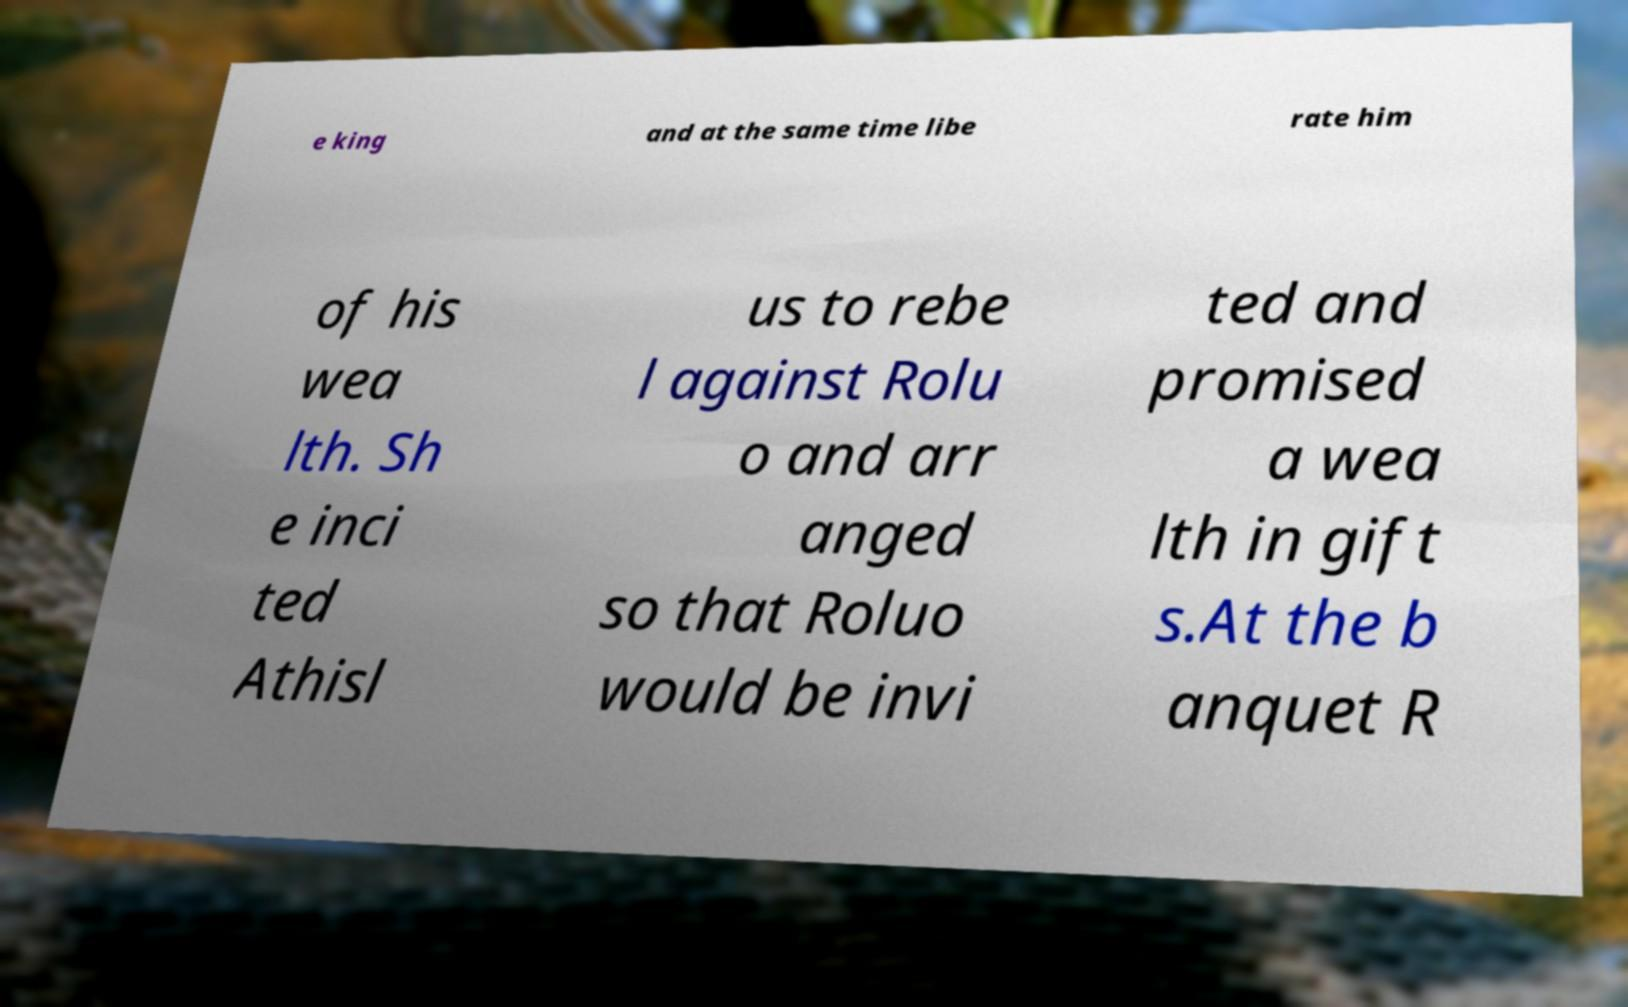Could you assist in decoding the text presented in this image and type it out clearly? e king and at the same time libe rate him of his wea lth. Sh e inci ted Athisl us to rebe l against Rolu o and arr anged so that Roluo would be invi ted and promised a wea lth in gift s.At the b anquet R 